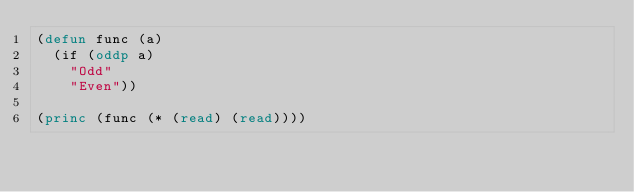Convert code to text. <code><loc_0><loc_0><loc_500><loc_500><_Lisp_>(defun func (a)
  (if (oddp a)
	"Odd"
	"Even"))

(princ (func (* (read) (read))))
</code> 